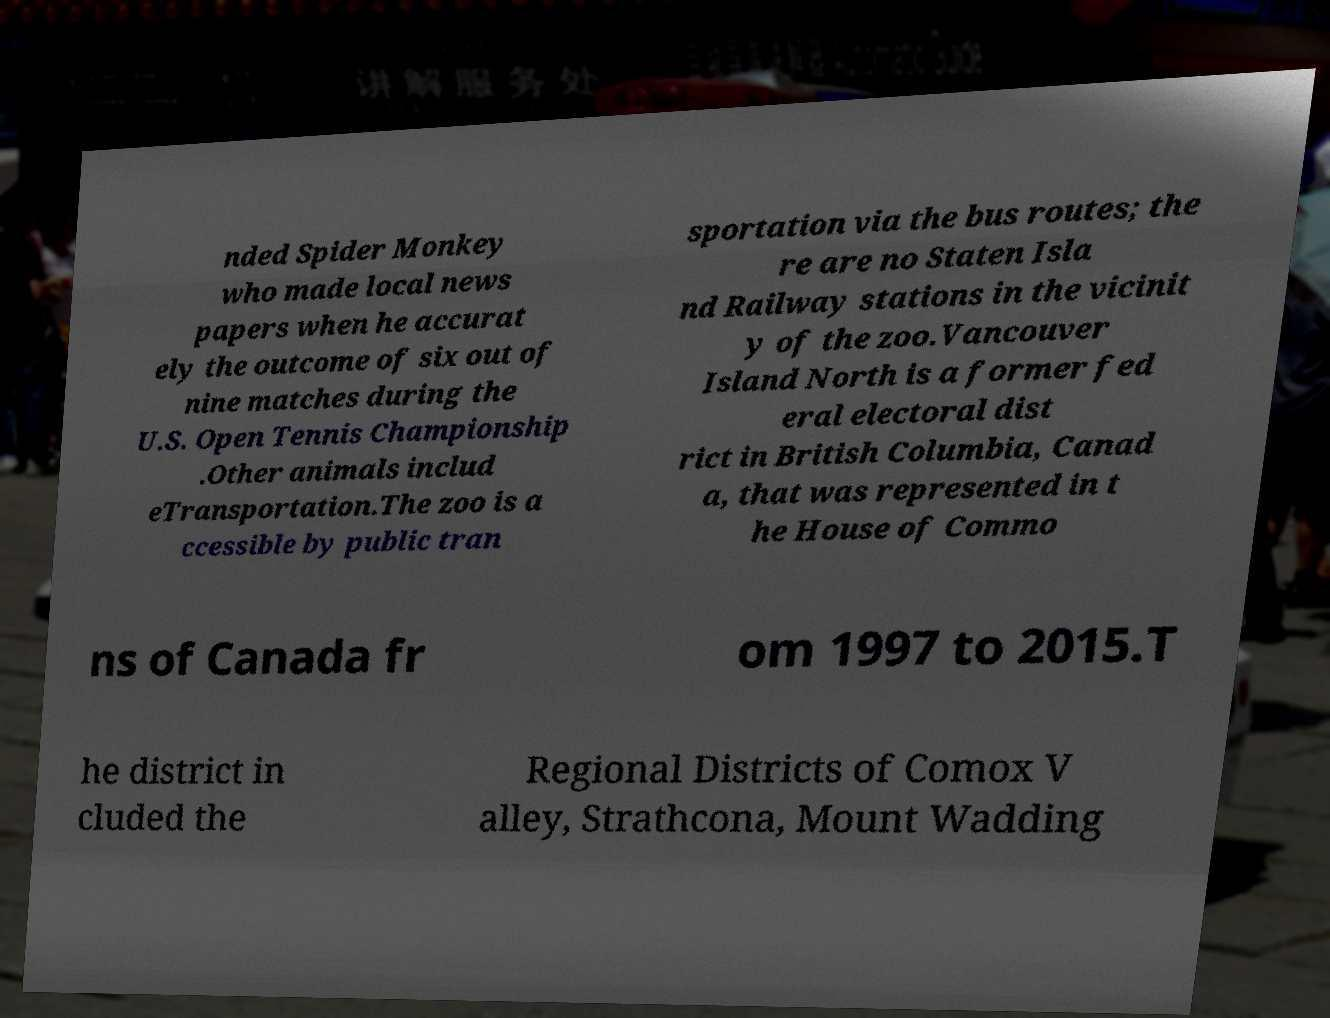Please read and relay the text visible in this image. What does it say? nded Spider Monkey who made local news papers when he accurat ely the outcome of six out of nine matches during the U.S. Open Tennis Championship .Other animals includ eTransportation.The zoo is a ccessible by public tran sportation via the bus routes; the re are no Staten Isla nd Railway stations in the vicinit y of the zoo.Vancouver Island North is a former fed eral electoral dist rict in British Columbia, Canad a, that was represented in t he House of Commo ns of Canada fr om 1997 to 2015.T he district in cluded the Regional Districts of Comox V alley, Strathcona, Mount Wadding 